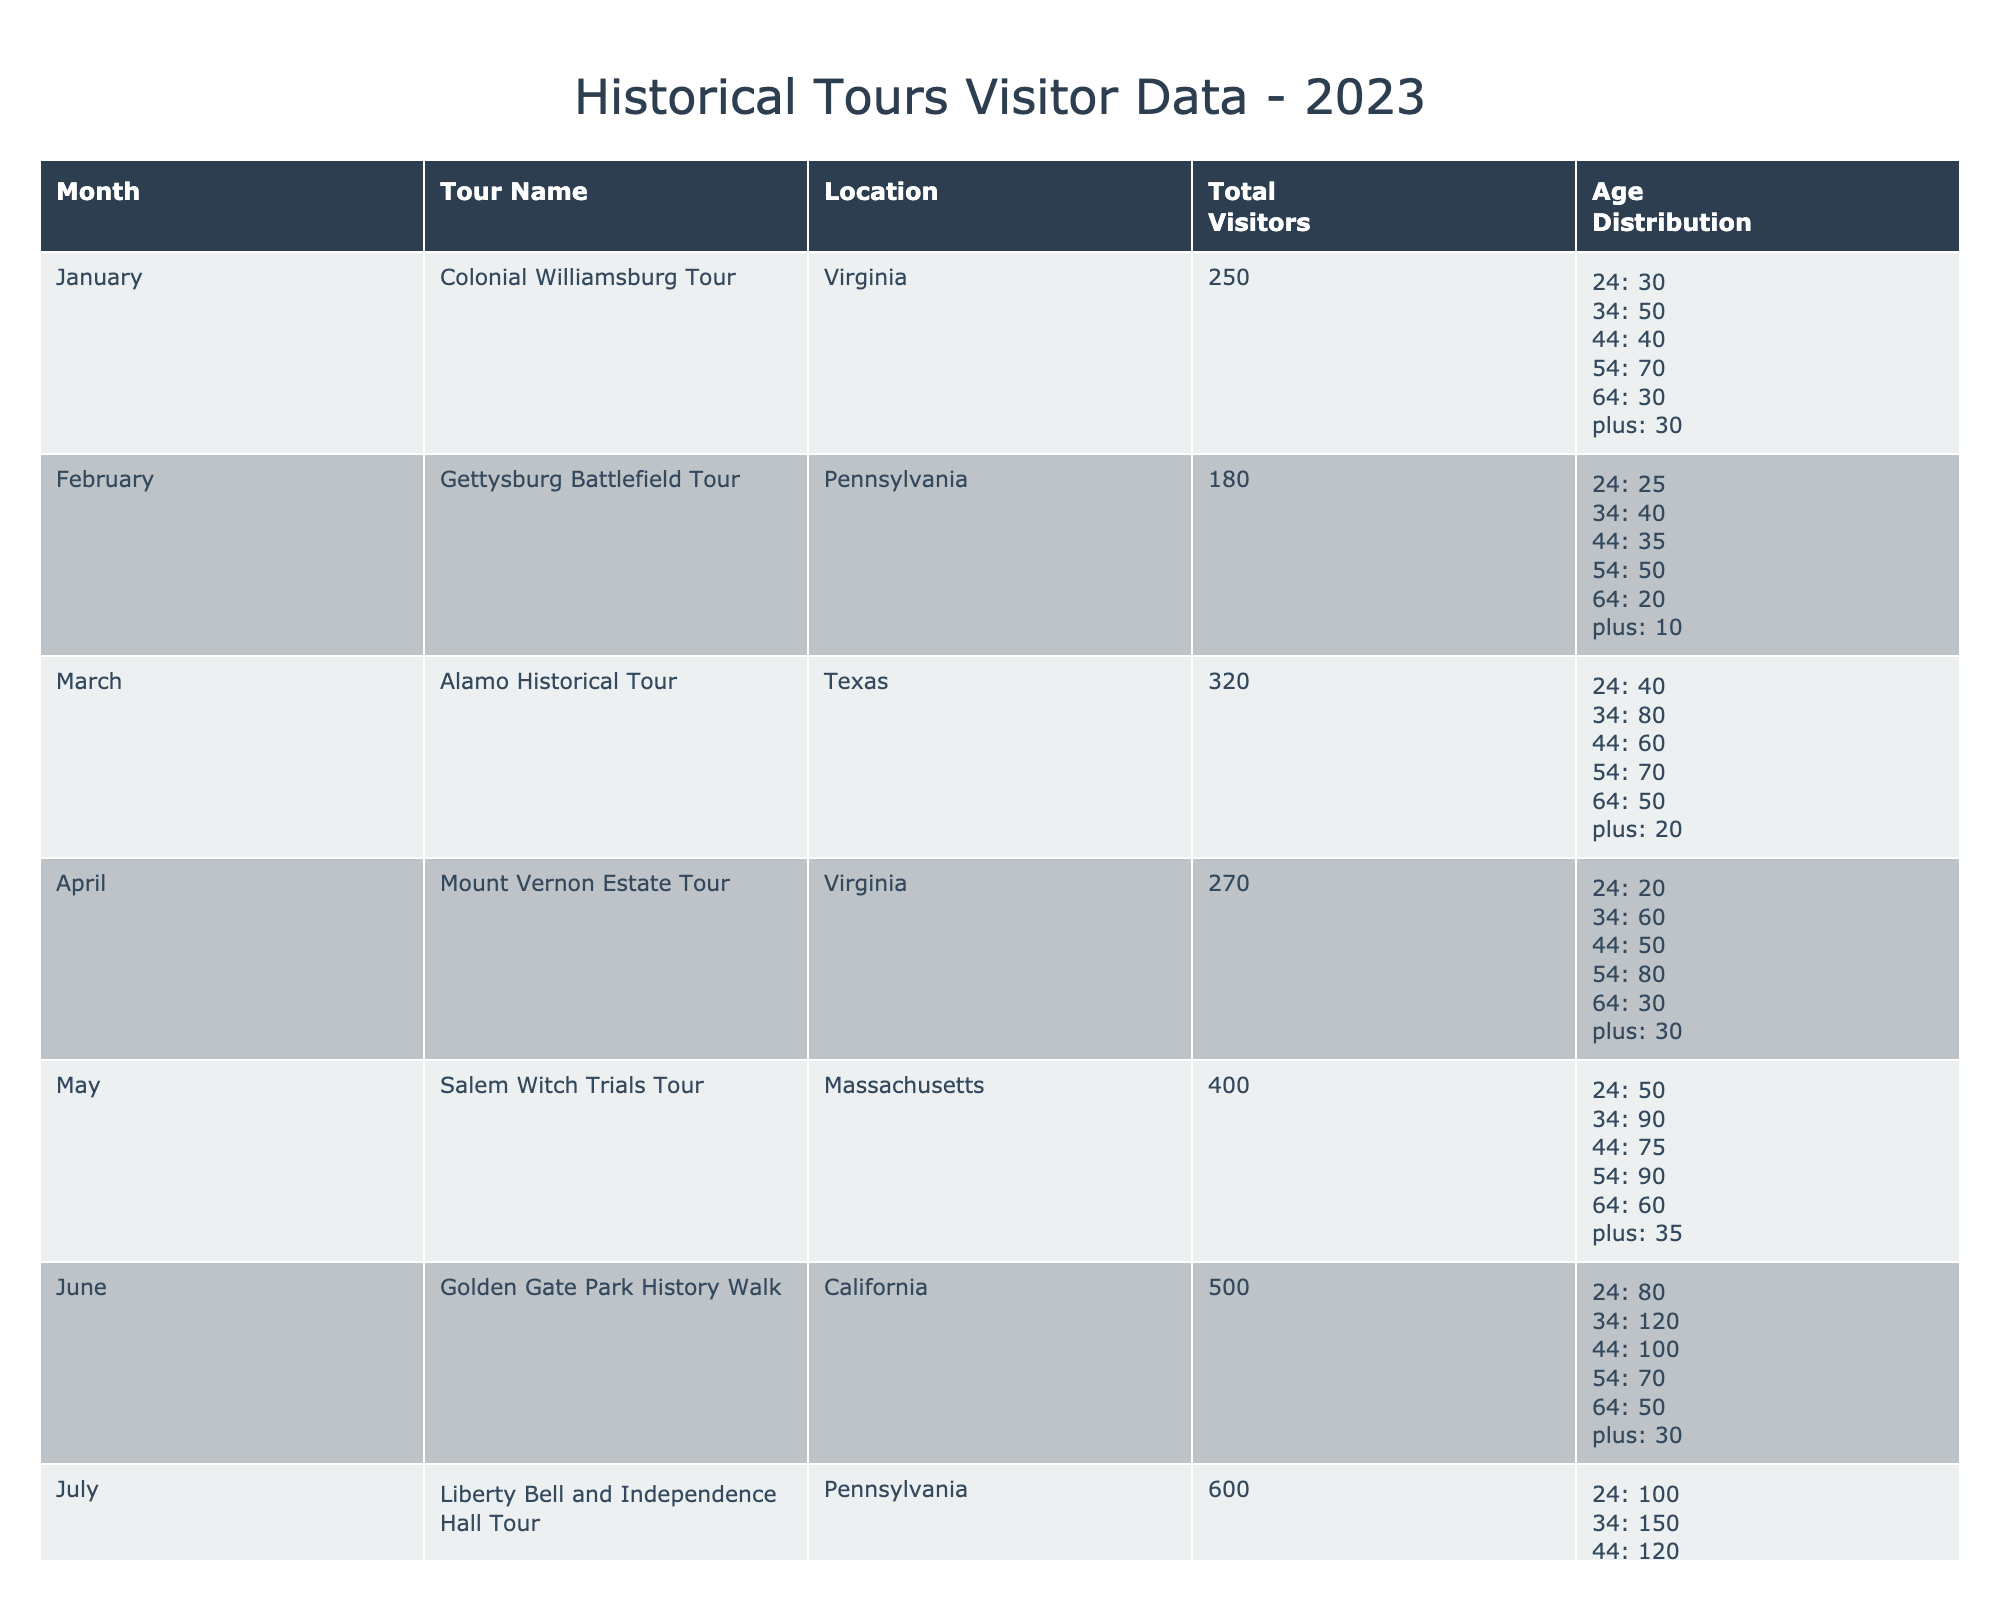What was the visitor count for the New York City Landmarks Tour? The table lists the New York City Landmarks Tour in September, showing a visitor count of 700.
Answer: 700 Which tour had the highest visitor count in 2023? The September New York City Landmarks Tour had the highest visitor count with 700 visitors, more than any other tour listed in the table.
Answer: New York City Landmarks Tour What is the total number of visitors for tours held in Virginia in 2023? The tours in Virginia are Colonial Williamsburg (250 visitors) and Mount Vernon Estate (270 visitors). Summing these gives 250 + 270 = 520 visitors.
Answer: 520 How many visitors aged 65 and older attended the Alamo Historical Tour in March? The Alamo Historical Tour had 20 visitors aged 65 and older, as indicated in the table.
Answer: 20 Did any tours have more than 500 visitors? Yes, the Golden Gate Park History Walk in June (500) and the Liberty Bell and Independence Hall Tour in July (600) did have more than 500 visitors.
Answer: Yes What was the average number of visitors for the tours in Massachusetts? The two Massachusetts tours are the Salem Witch Trials Tour (400 visitors) and The Freedom Trail Tour (360 visitors). Adding these gives 400 + 360 = 760. Dividing by 2 results in an average of 760 / 2 = 380 visitors.
Answer: 380 How many visitors attended the Haunted History Tours compared to the Gettysburg Battlefield Tour? The Haunted History Tours had 540 visitors, while the Gettysburg Battlefield Tour had 180 visitors. The difference is 540 - 180 = 360 more visitors for the Haunted History Tours.
Answer: 360 Which age group had the highest representation in the Liberty Bell and Independence Hall Tour? For the Liberty Bell and Independence Hall Tour, the highest count is in the age group 25-34 with 150 visitors, according to the table.
Answer: Age Group 25-34 Calculate the total number of visitors across all tours in December and January. For December, there were 280 visitors and for January, there were 250 visitors. Adding these gives 280 + 250 = 530 visitors total for December and January.
Answer: 530 What percentage of visitors in May were aged 45-54? In May, there were 400 total visitors and 90 aged 45-54. To find the percentage, calculate (90 / 400) * 100 = 22.5%.
Answer: 22.5% 